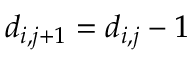Convert formula to latex. <formula><loc_0><loc_0><loc_500><loc_500>d _ { i , j + 1 } = d _ { i , j } - 1</formula> 